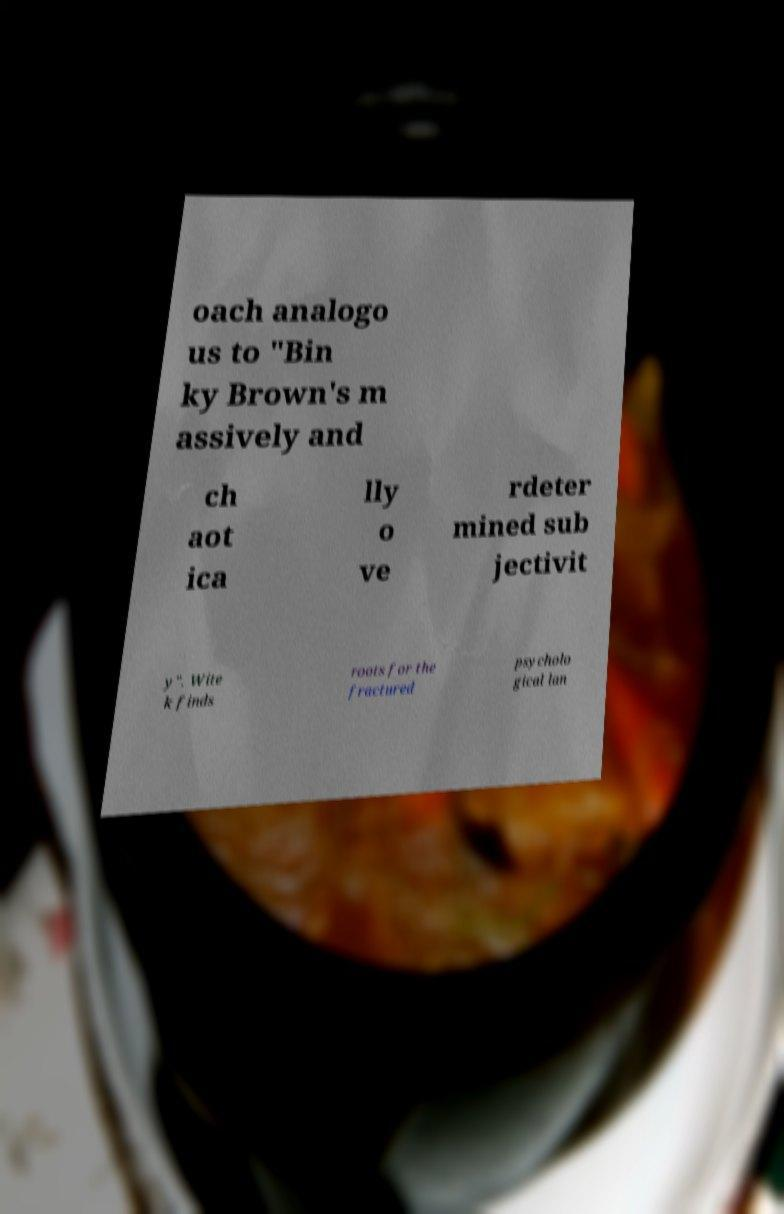Can you accurately transcribe the text from the provided image for me? oach analogo us to "Bin ky Brown's m assively and ch aot ica lly o ve rdeter mined sub jectivit y". Wite k finds roots for the fractured psycholo gical lan 